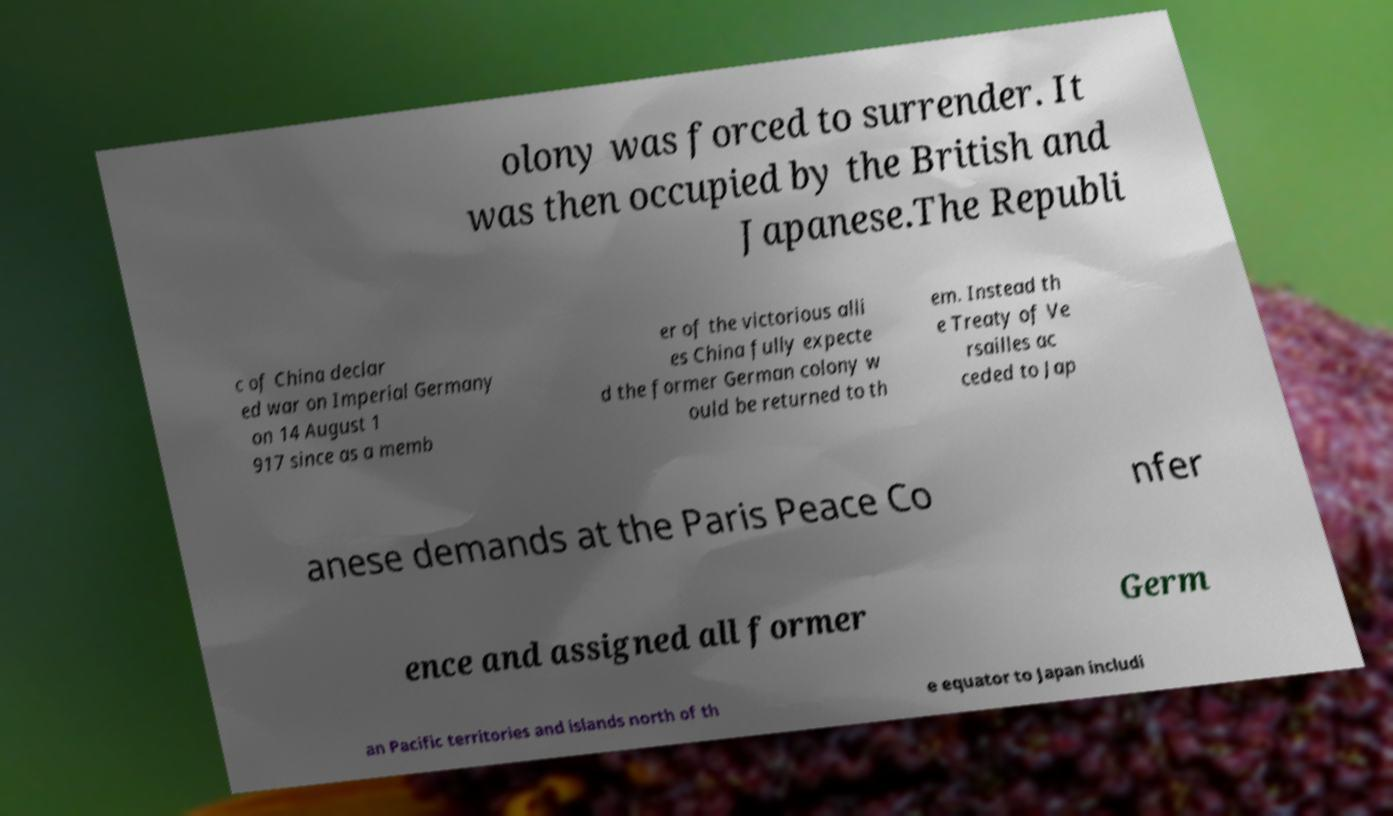What messages or text are displayed in this image? I need them in a readable, typed format. olony was forced to surrender. It was then occupied by the British and Japanese.The Republi c of China declar ed war on Imperial Germany on 14 August 1 917 since as a memb er of the victorious alli es China fully expecte d the former German colony w ould be returned to th em. Instead th e Treaty of Ve rsailles ac ceded to Jap anese demands at the Paris Peace Co nfer ence and assigned all former Germ an Pacific territories and islands north of th e equator to Japan includi 